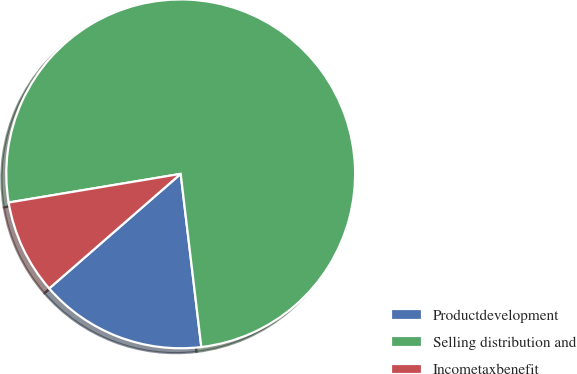<chart> <loc_0><loc_0><loc_500><loc_500><pie_chart><fcel>Productdevelopment<fcel>Selling distribution and<fcel>Incometaxbenefit<nl><fcel>15.48%<fcel>75.74%<fcel>8.78%<nl></chart> 